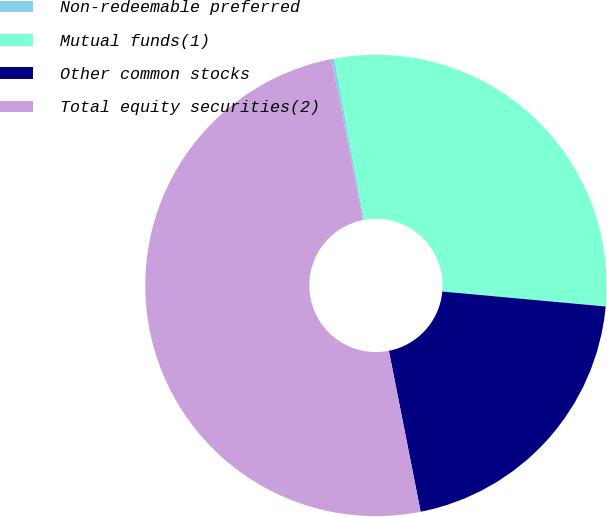Convert chart to OTSL. <chart><loc_0><loc_0><loc_500><loc_500><pie_chart><fcel>Non-redeemable preferred<fcel>Mutual funds(1)<fcel>Other common stocks<fcel>Total equity securities(2)<nl><fcel>0.21%<fcel>29.34%<fcel>20.44%<fcel>50.0%<nl></chart> 